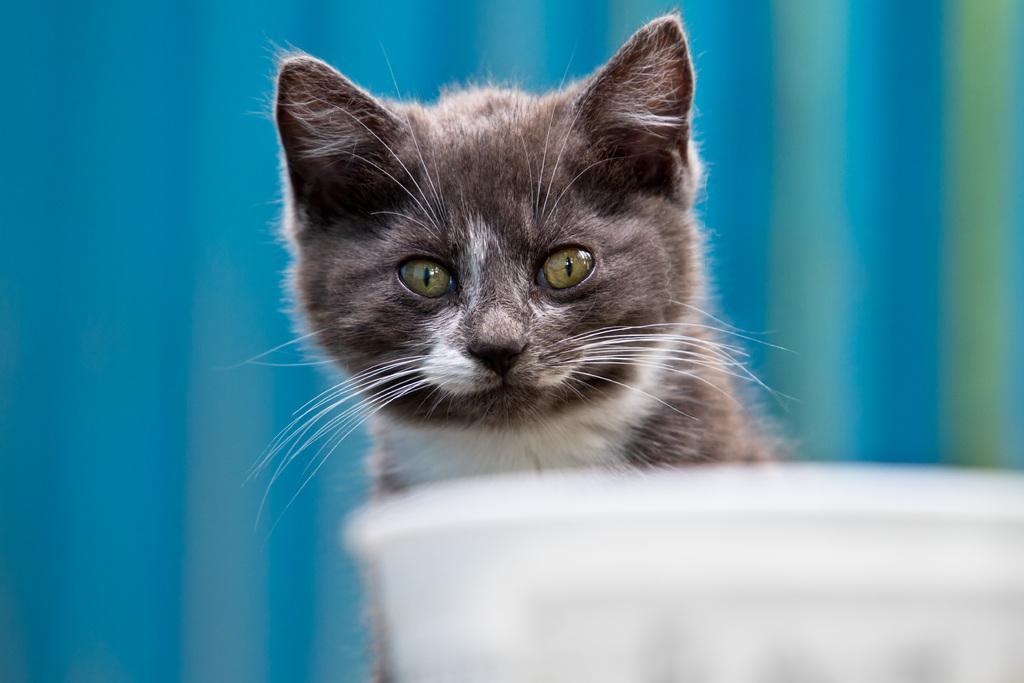Please provide a concise description of this image. In this image we can see one cat, one white color object looks like a bowl on the bottom right side of the image, there is a blue with light green lines background and the image is blurred. 